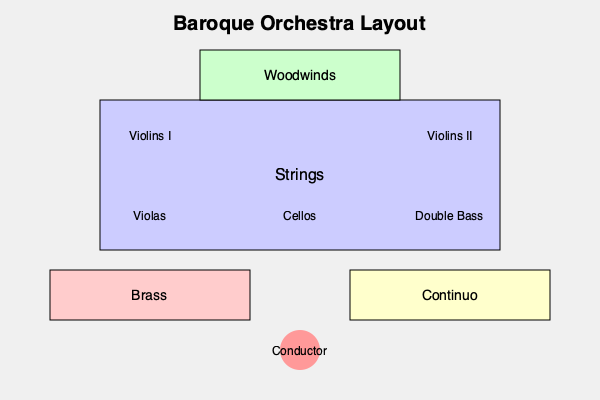In a typical Baroque orchestra, which section forms the core of the ensemble and is usually placed centrally in the layout? To answer this question, let's examine the structure and layout of a typical Baroque orchestra:

1. The diagram shows a bird's-eye view of a Baroque orchestra layout.

2. At the center and largest section of the orchestra, we see the strings. This includes:
   - Violins I and II
   - Violas
   - Cellos
   - Double Bass

3. The string section forms a rectangle in the middle of the ensemble, occupying the most space.

4. Other sections are positioned around the strings:
   - Woodwinds are placed behind the strings
   - Brass is on one side
   - Continuo (which typically includes harpsichord and other bass instruments) is on the other side

5. The conductor is positioned at the front of the orchestra.

6. This central placement of strings reflects their importance in Baroque music. They provide the main body of sound and are often the focus of compositions, especially in works by composers like Bach.

7. The string section's central position also allows for better balance and blend with other sections of the orchestra.

Therefore, the string section forms the core of a typical Baroque orchestra and is usually placed centrally in the layout.
Answer: Strings 